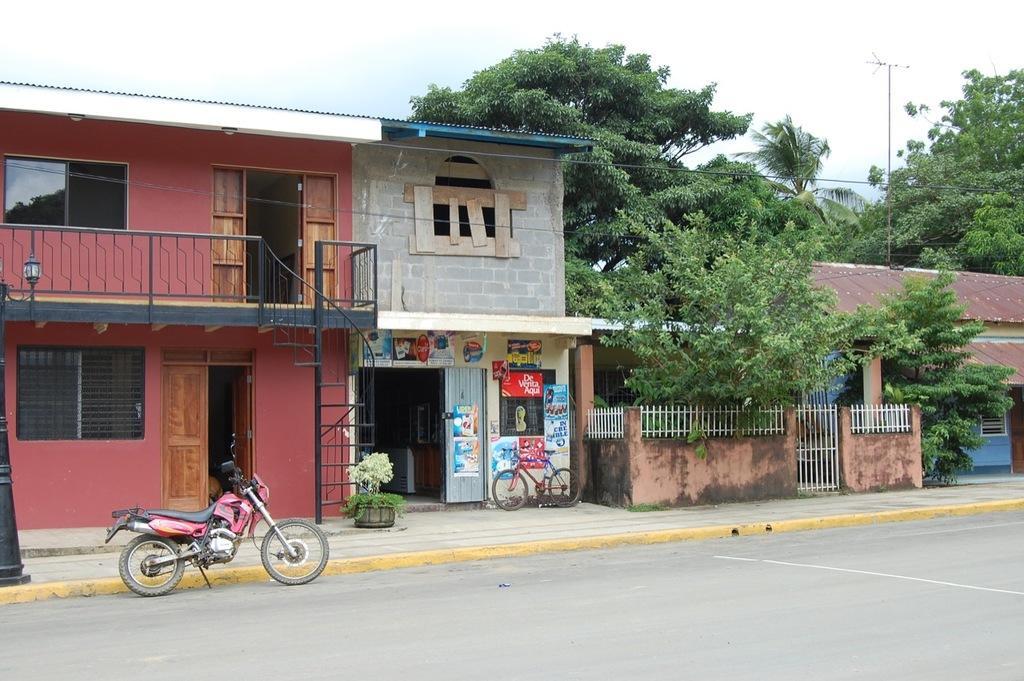Describe this image in one or two sentences. In this image I can see the road, a motor bike which is red and black in color, the sidewalk, few trees, few buildings, a bicycle and in the background I can see the sky. 